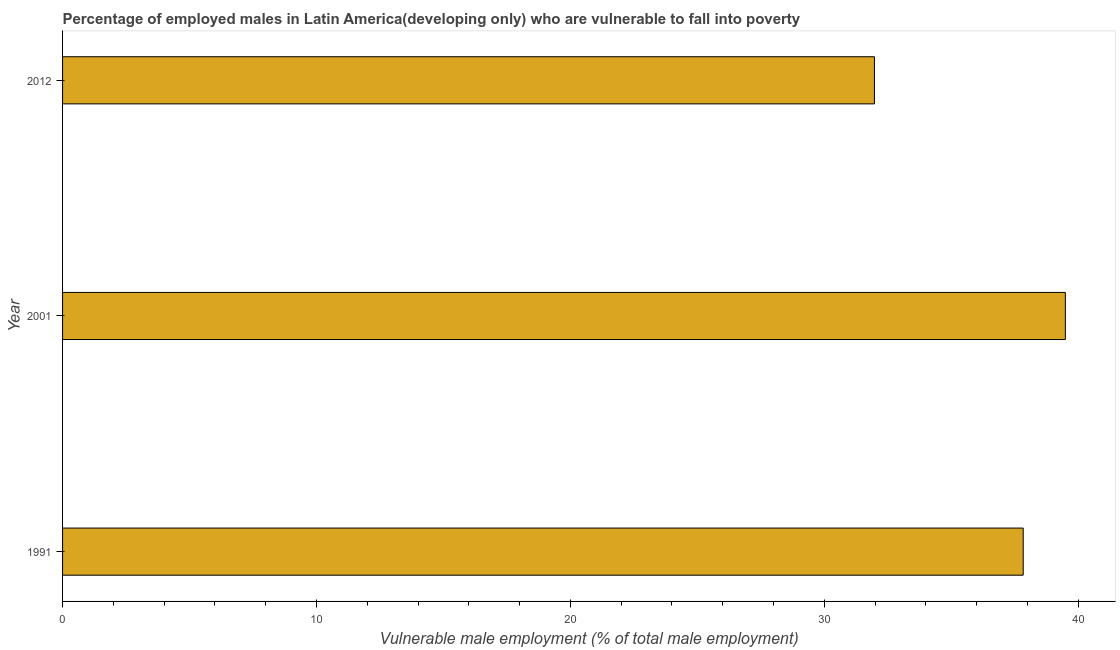Does the graph contain any zero values?
Provide a short and direct response. No. What is the title of the graph?
Your answer should be compact. Percentage of employed males in Latin America(developing only) who are vulnerable to fall into poverty. What is the label or title of the X-axis?
Make the answer very short. Vulnerable male employment (% of total male employment). What is the percentage of employed males who are vulnerable to fall into poverty in 2001?
Make the answer very short. 39.49. Across all years, what is the maximum percentage of employed males who are vulnerable to fall into poverty?
Give a very brief answer. 39.49. Across all years, what is the minimum percentage of employed males who are vulnerable to fall into poverty?
Your answer should be compact. 31.97. In which year was the percentage of employed males who are vulnerable to fall into poverty minimum?
Offer a very short reply. 2012. What is the sum of the percentage of employed males who are vulnerable to fall into poverty?
Your answer should be very brief. 109.3. What is the difference between the percentage of employed males who are vulnerable to fall into poverty in 2001 and 2012?
Keep it short and to the point. 7.52. What is the average percentage of employed males who are vulnerable to fall into poverty per year?
Give a very brief answer. 36.43. What is the median percentage of employed males who are vulnerable to fall into poverty?
Offer a very short reply. 37.83. In how many years, is the percentage of employed males who are vulnerable to fall into poverty greater than 34 %?
Keep it short and to the point. 2. What is the ratio of the percentage of employed males who are vulnerable to fall into poverty in 2001 to that in 2012?
Give a very brief answer. 1.24. Is the difference between the percentage of employed males who are vulnerable to fall into poverty in 1991 and 2001 greater than the difference between any two years?
Provide a succinct answer. No. What is the difference between the highest and the second highest percentage of employed males who are vulnerable to fall into poverty?
Your answer should be very brief. 1.66. What is the difference between the highest and the lowest percentage of employed males who are vulnerable to fall into poverty?
Your answer should be very brief. 7.52. How many bars are there?
Make the answer very short. 3. Are all the bars in the graph horizontal?
Your answer should be compact. Yes. How many years are there in the graph?
Your answer should be very brief. 3. Are the values on the major ticks of X-axis written in scientific E-notation?
Offer a very short reply. No. What is the Vulnerable male employment (% of total male employment) of 1991?
Give a very brief answer. 37.83. What is the Vulnerable male employment (% of total male employment) of 2001?
Offer a very short reply. 39.49. What is the Vulnerable male employment (% of total male employment) in 2012?
Your response must be concise. 31.97. What is the difference between the Vulnerable male employment (% of total male employment) in 1991 and 2001?
Offer a terse response. -1.66. What is the difference between the Vulnerable male employment (% of total male employment) in 1991 and 2012?
Ensure brevity in your answer.  5.86. What is the difference between the Vulnerable male employment (% of total male employment) in 2001 and 2012?
Make the answer very short. 7.52. What is the ratio of the Vulnerable male employment (% of total male employment) in 1991 to that in 2001?
Ensure brevity in your answer.  0.96. What is the ratio of the Vulnerable male employment (% of total male employment) in 1991 to that in 2012?
Your answer should be very brief. 1.18. What is the ratio of the Vulnerable male employment (% of total male employment) in 2001 to that in 2012?
Keep it short and to the point. 1.24. 